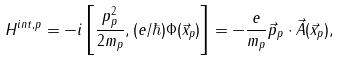<formula> <loc_0><loc_0><loc_500><loc_500>H ^ { i n t , p } = - i \left [ \frac { p _ { p } ^ { 2 } } { 2 m _ { p } } , ( e / \hbar { ) } \Phi ( \vec { x } _ { p } ) \right ] = - \frac { e } { m _ { p } } \vec { p } _ { p } \cdot \vec { A } ( \vec { x } _ { p } ) ,</formula> 